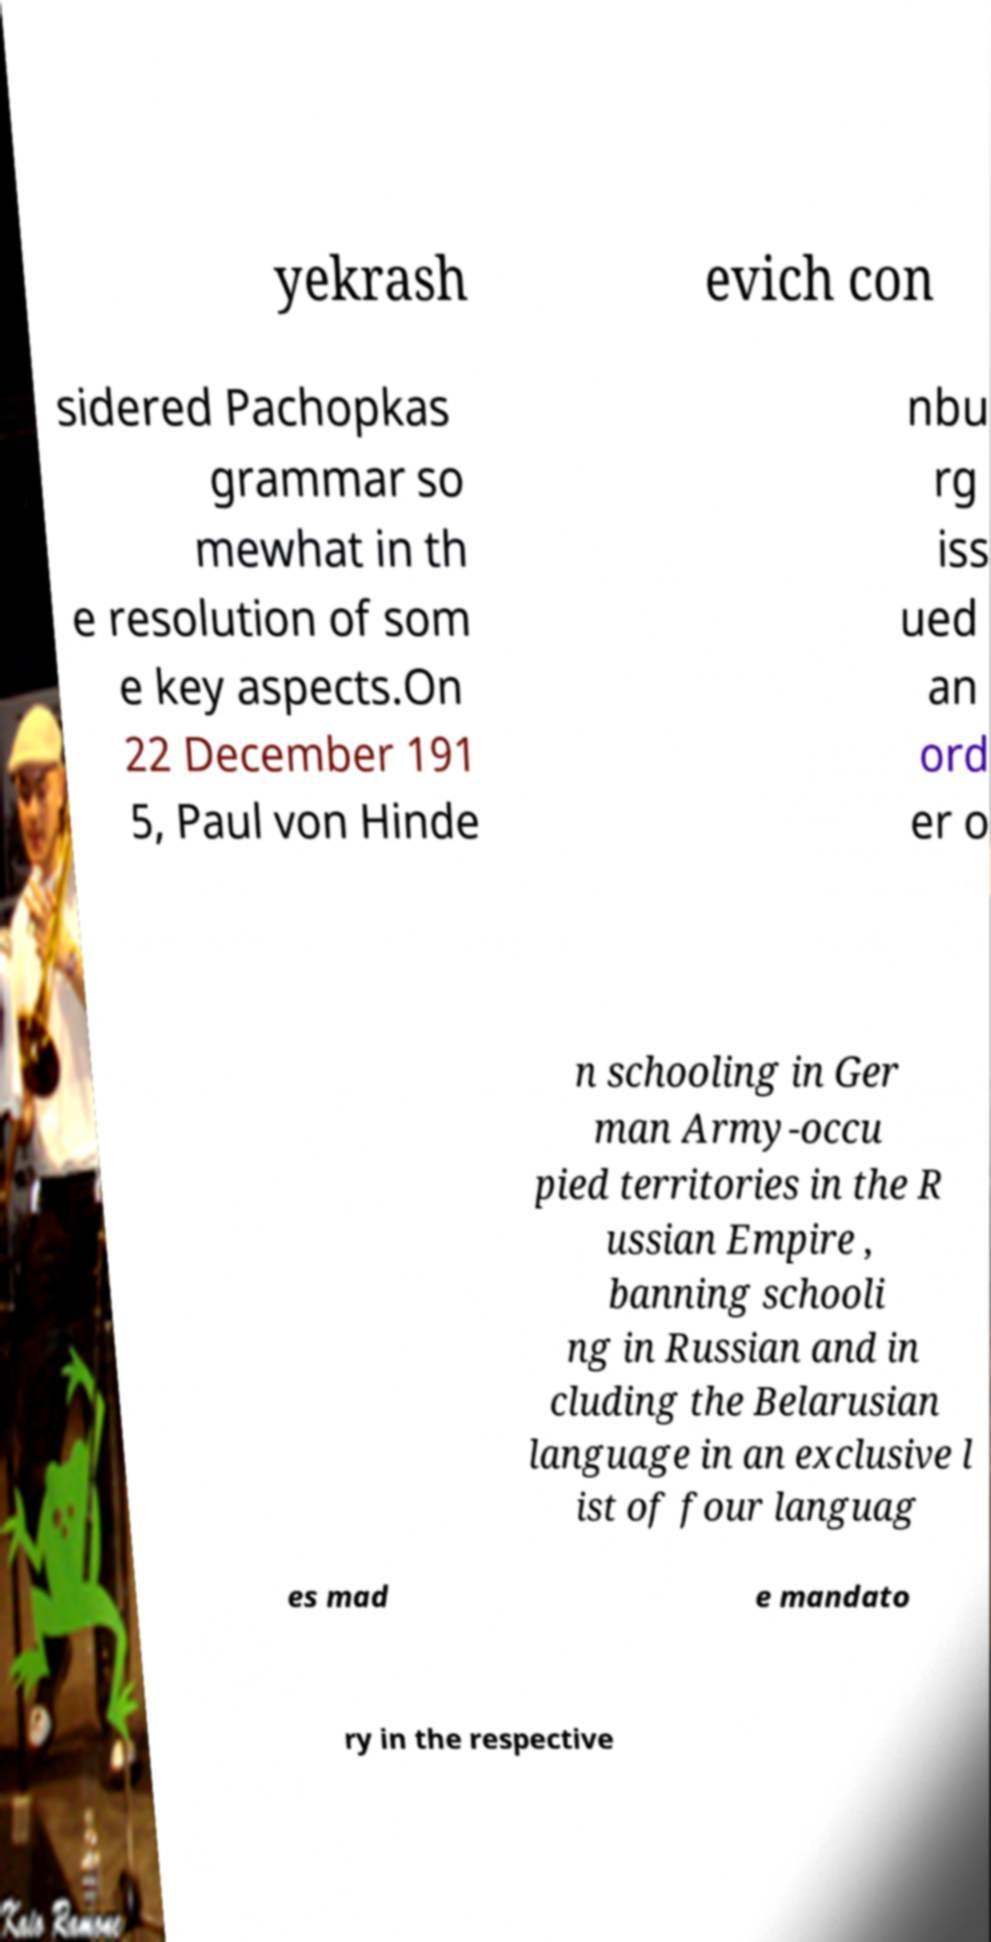For documentation purposes, I need the text within this image transcribed. Could you provide that? yekrash evich con sidered Pachopkas grammar so mewhat in th e resolution of som e key aspects.On 22 December 191 5, Paul von Hinde nbu rg iss ued an ord er o n schooling in Ger man Army-occu pied territories in the R ussian Empire , banning schooli ng in Russian and in cluding the Belarusian language in an exclusive l ist of four languag es mad e mandato ry in the respective 